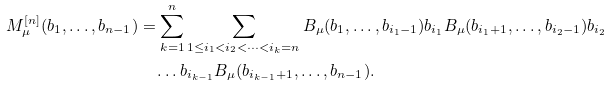<formula> <loc_0><loc_0><loc_500><loc_500>M _ { \mu } ^ { [ n ] } ( b _ { 1 } , \dots , b _ { n - 1 } ) & = \sum _ { k = 1 } ^ { n } \sum _ { 1 \leq i _ { 1 } < i _ { 2 } < \dots < i _ { k } = n } B _ { \mu } ( b _ { 1 } , \dots , b _ { i _ { 1 } - 1 } ) b _ { i _ { 1 } } B _ { \mu } ( b _ { i _ { 1 } + 1 } , \dots , b _ { i _ { 2 } - 1 } ) b _ { i _ { 2 } } \\ & \quad \dots b _ { i _ { k - 1 } } B _ { \mu } ( b _ { i _ { k - 1 } + 1 } , \dots , b _ { n - 1 } ) .</formula> 